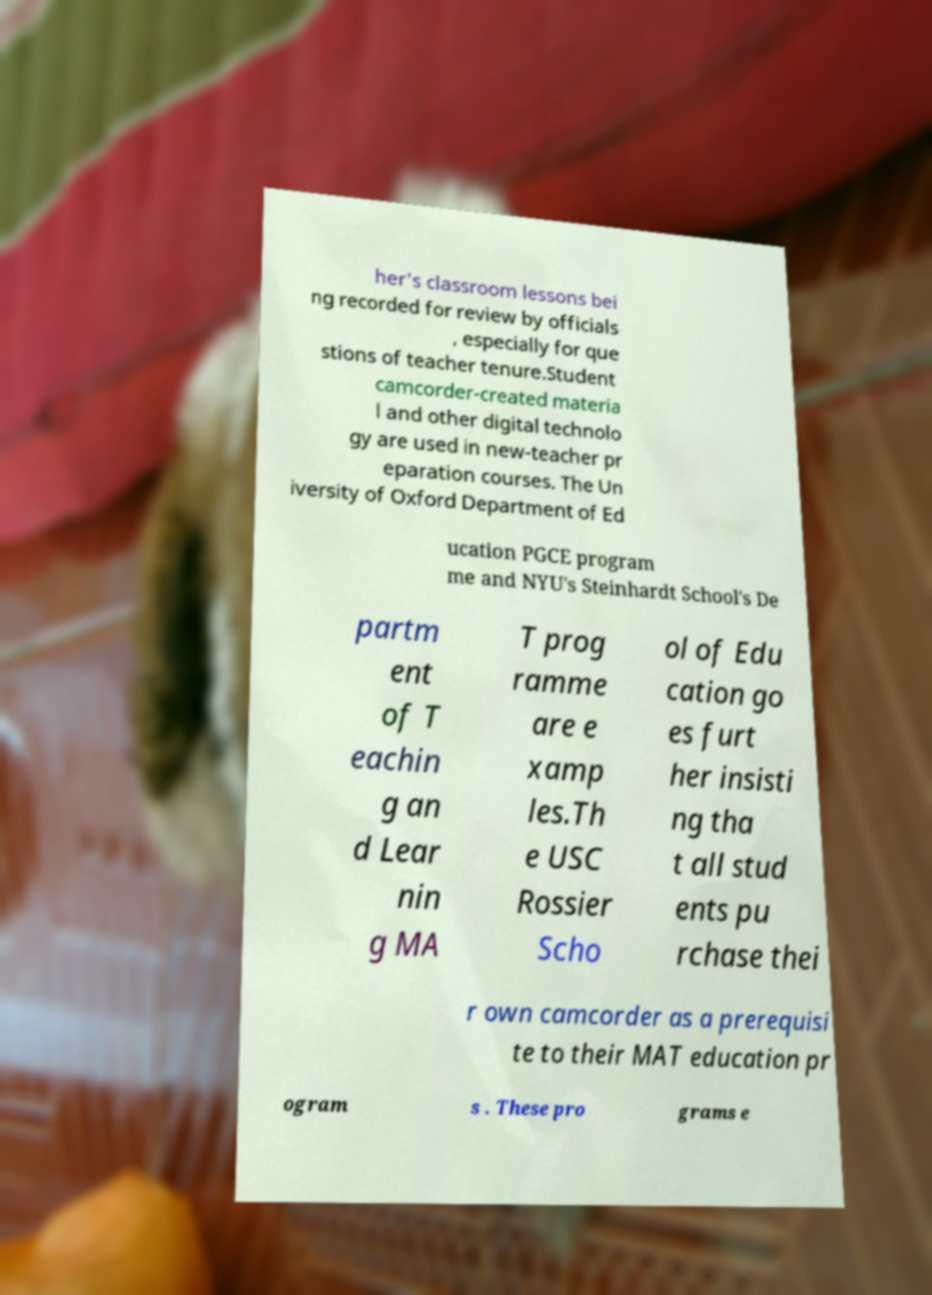There's text embedded in this image that I need extracted. Can you transcribe it verbatim? her's classroom lessons bei ng recorded for review by officials , especially for que stions of teacher tenure.Student camcorder-created materia l and other digital technolo gy are used in new-teacher pr eparation courses. The Un iversity of Oxford Department of Ed ucation PGCE program me and NYU's Steinhardt School's De partm ent of T eachin g an d Lear nin g MA T prog ramme are e xamp les.Th e USC Rossier Scho ol of Edu cation go es furt her insisti ng tha t all stud ents pu rchase thei r own camcorder as a prerequisi te to their MAT education pr ogram s . These pro grams e 